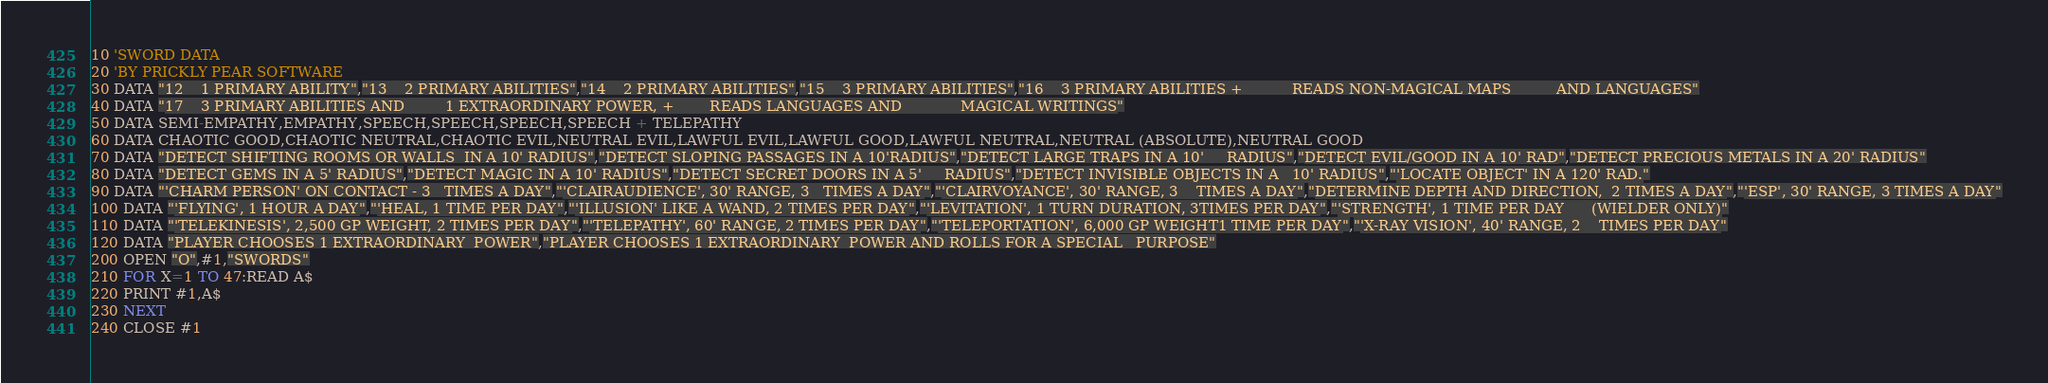<code> <loc_0><loc_0><loc_500><loc_500><_VisualBasic_>10 'SWORD DATA20 'BY PRICKLY PEAR SOFTWARE30 DATA "12    1 PRIMARY ABILITY","13    2 PRIMARY ABILITIES","14    2 PRIMARY ABILITIES","15    3 PRIMARY ABILITIES","16    3 PRIMARY ABILITIES +           READS NON-MAGICAL MAPS          AND LANGUAGES"40 DATA "17    3 PRIMARY ABILITIES AND         1 EXTRAORDINARY POWER, +        READS LANGUAGES AND             MAGICAL WRITINGS"50 DATA SEMI-EMPATHY,EMPATHY,SPEECH,SPEECH,SPEECH,SPEECH + TELEPATHY60 DATA CHAOTIC GOOD,CHAOTIC NEUTRAL,CHAOTIC EVIL,NEUTRAL EVIL,LAWFUL EVIL,LAWFUL GOOD,LAWFUL NEUTRAL,NEUTRAL (ABSOLUTE),NEUTRAL GOOD70 DATA "DETECT SHIFTING ROOMS OR WALLS  IN A 10' RADIUS","DETECT SLOPING PASSAGES IN A 10'RADIUS","DETECT LARGE TRAPS IN A 10'     RADIUS","DETECT EVIL/GOOD IN A 10' RAD","DETECT PRECIOUS METALS IN A 20' RADIUS"80 DATA "DETECT GEMS IN A 5' RADIUS","DETECT MAGIC IN A 10' RADIUS","DETECT SECRET DOORS IN A 5'     RADIUS","DETECT INVISIBLE OBJECTS IN A   10' RADIUS","'LOCATE OBJECT' IN A 120' RAD."90 DATA "'CHARM PERSON' ON CONTACT - 3   TIMES A DAY","'CLAIRAUDIENCE', 30' RANGE, 3   TIMES A DAY","'CLAIRVOYANCE', 30' RANGE, 3    TIMES A DAY","DETERMINE DEPTH AND DIRECTION,  2 TIMES A DAY","'ESP', 30' RANGE, 3 TIMES A DAY"100 DATA "'FLYING', 1 HOUR A DAY","'HEAL, 1 TIME PER DAY","'ILLUSION' LIKE A WAND, 2 TIMES PER DAY","'LEVITATION', 1 TURN DURATION, 3TIMES PER DAY","'STRENGTH', 1 TIME PER DAY      (WIELDER ONLY)"110 DATA "'TELEKINESIS', 2,500 GP WEIGHT, 2 TIMES PER DAY","'TELEPATHY', 60' RANGE, 2 TIMES PER DAY","'TELEPORTATION', 6,000 GP WEIGHT1 TIME PER DAY","'X-RAY VISION', 40' RANGE, 2    TIMES PER DAY"120 DATA "PLAYER CHOOSES 1 EXTRAORDINARY  POWER","PLAYER CHOOSES 1 EXTRAORDINARY  POWER AND ROLLS FOR A SPECIAL   PURPOSE"200 OPEN "O",#1,"SWORDS"210 FOR X=1 TO 47:READ A$220 PRINT #1,A$230 NEXT240 CLOSE #1</code> 